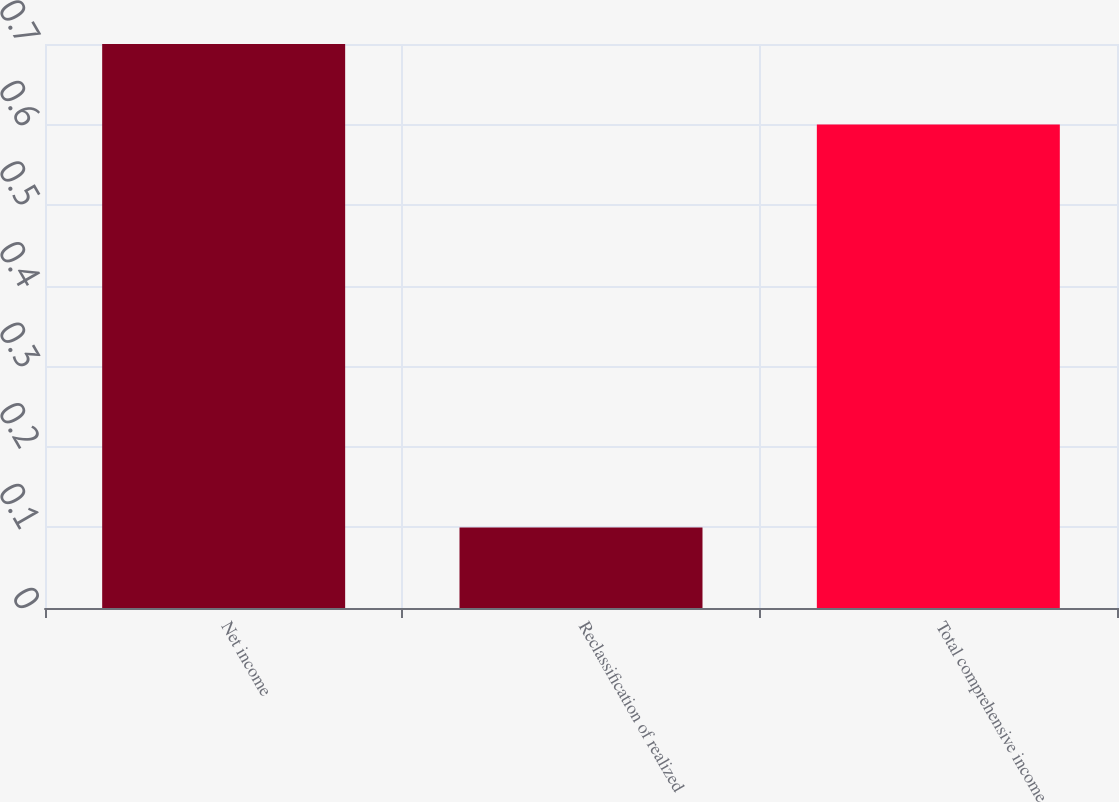Convert chart. <chart><loc_0><loc_0><loc_500><loc_500><bar_chart><fcel>Net income<fcel>Reclassification of realized<fcel>Total comprehensive income<nl><fcel>0.7<fcel>0.1<fcel>0.6<nl></chart> 